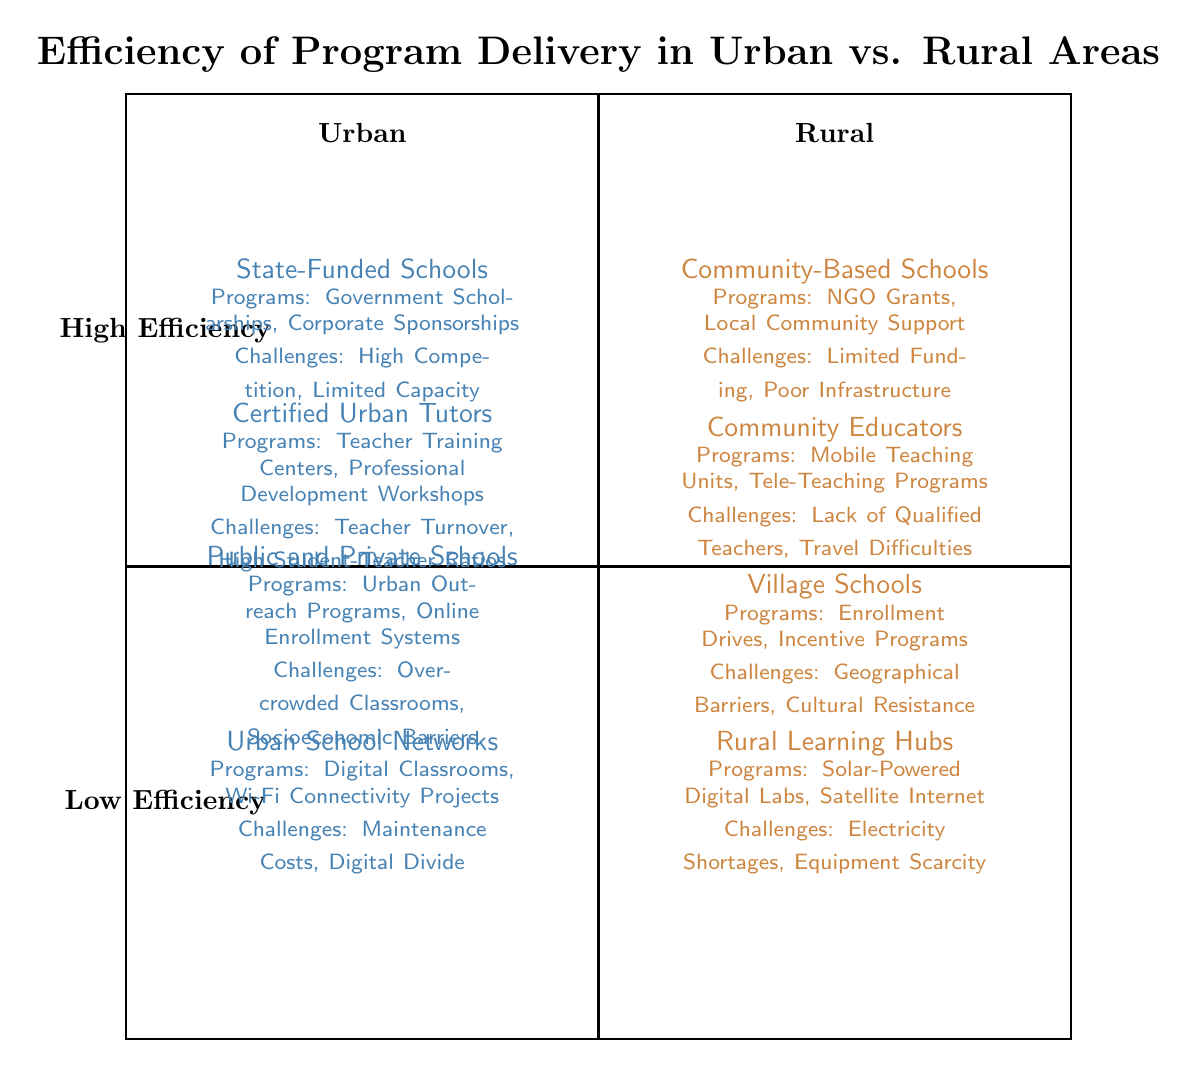What educational entity serves urban areas? The diagram shows that "State-Funded Schools" serve urban areas as indicated within the urban quadrant.
Answer: State-Funded Schools What programs support access to resources in rural areas? The rural quadrant lists "NGO Grants" and "Local Community Support" as the programs available to support access to resources in rural areas.
Answer: NGO Grants, Local Community Support Which area faces challenges with "High Competition"? The diagram associates "High Competition" under the challenges for urban access to resources, indicating this issue affects the urban area.
Answer: Urban How many nodes describe different educational entities in total? The diagram has four educational entities listed: State-Funded Schools, Certified Urban Tutors, Public and Private Schools, and Urban School Networks in urban; and Community-Based Schools, Community Educators, Village Schools, and Rural Learning Hubs in rural, totaling eight nodes.
Answer: Eight What is a major challenge for teacher availability in rural areas? The rural quadrant outlines "Lack of Qualified Teachers" as a significant challenge for teacher availability in rural areas, requiring focus on educator qualifications.
Answer: Lack of Qualified Teachers Which program is associated with urban technological infrastructure? The urban quadrant indicates "Digital Classrooms" within the technological infrastructure section, showing this program's relevance to urban areas.
Answer: Digital Classrooms Which rural program aims at student enrollment? "Enrollment Drives" is listed under the rural segment focusing on student enrollment, highlighting its importance in rural education strategies.
Answer: Enrollment Drives What do both urban and rural areas face regarding infrastructure? Both quadrants have specific challenges: urban deals with "Maintenance Costs" while rural addresses "Electricity Shortages," showing varied infrastructure concerns.
Answer: Maintenance Costs, Electricity Shortages What is indicated as a high-efficiency program delivery in urban areas? The diagram reflects that both Community-Based Schools and Certified Urban Tutors are situated in the high-efficiency zone for urban areas, suggesting these programs excel in delivery.
Answer: Community-Based Schools, Certified Urban Tutors 